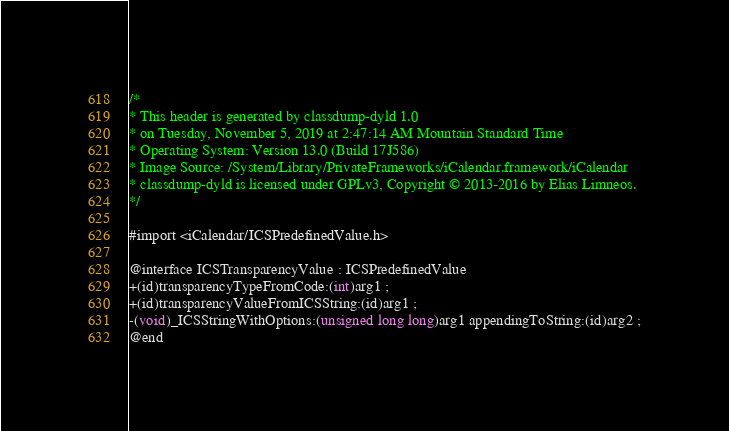<code> <loc_0><loc_0><loc_500><loc_500><_C_>/*
* This header is generated by classdump-dyld 1.0
* on Tuesday, November 5, 2019 at 2:47:14 AM Mountain Standard Time
* Operating System: Version 13.0 (Build 17J586)
* Image Source: /System/Library/PrivateFrameworks/iCalendar.framework/iCalendar
* classdump-dyld is licensed under GPLv3, Copyright © 2013-2016 by Elias Limneos.
*/

#import <iCalendar/ICSPredefinedValue.h>

@interface ICSTransparencyValue : ICSPredefinedValue
+(id)transparencyTypeFromCode:(int)arg1 ;
+(id)transparencyValueFromICSString:(id)arg1 ;
-(void)_ICSStringWithOptions:(unsigned long long)arg1 appendingToString:(id)arg2 ;
@end

</code> 